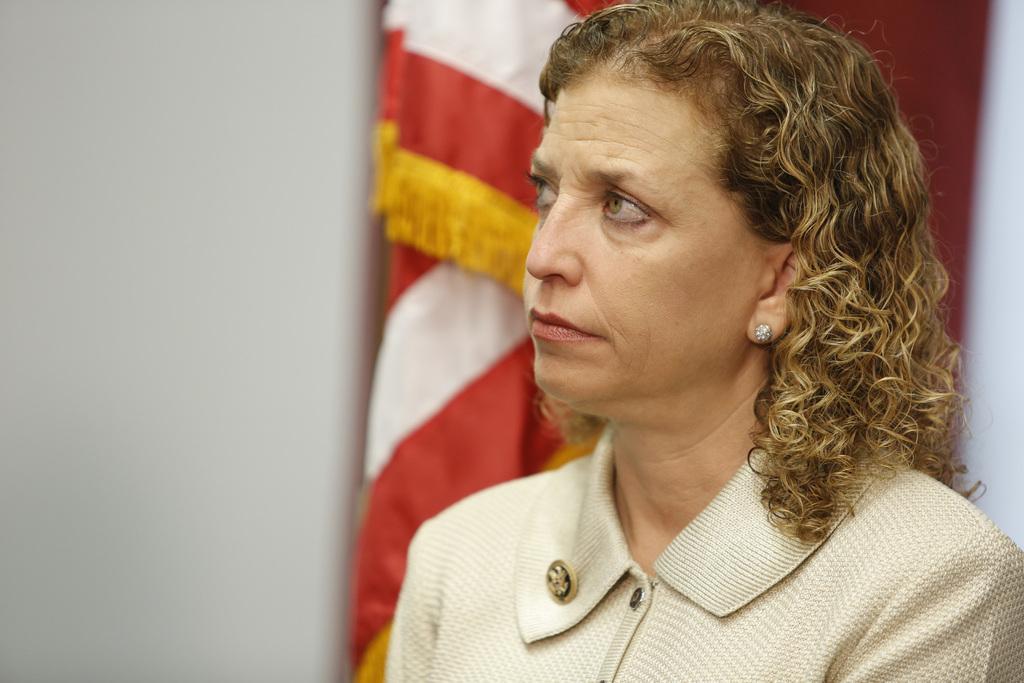Can you describe this image briefly? In this image there is a woman, in the background there is a flag and a wall and it is blurred. 